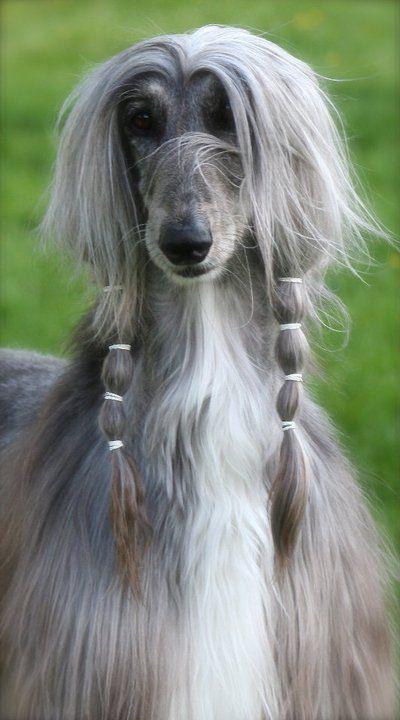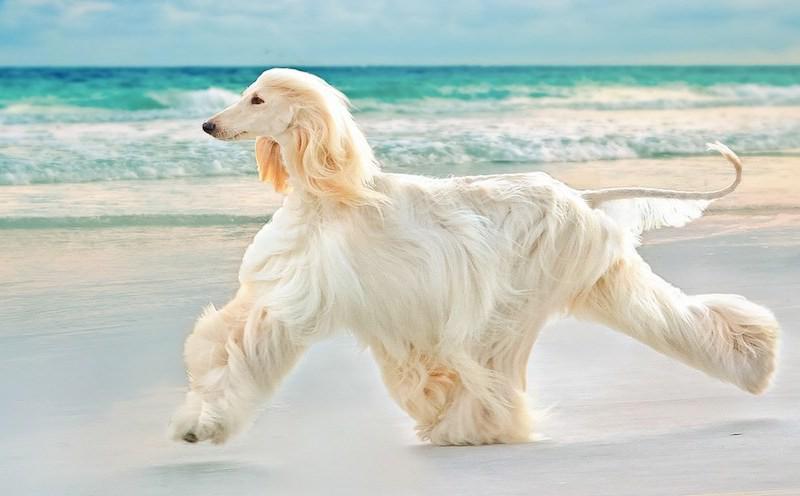The first image is the image on the left, the second image is the image on the right. For the images displayed, is the sentence "There is a dog's face in the left image with greenery behind it." factually correct? Answer yes or no. Yes. 